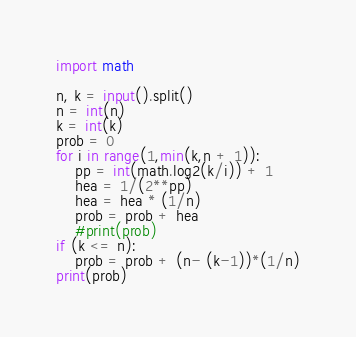<code> <loc_0><loc_0><loc_500><loc_500><_Python_>import math

n, k = input().split()
n = int(n)
k = int(k)
prob = 0
for i in range(1,min(k,n + 1)):
    pp = int(math.log2(k/i)) + 1    
    hea = 1/(2**pp)
    hea = hea * (1/n)
    prob = prob + hea
    #print(prob)
if (k <= n):
    prob = prob + (n- (k-1))*(1/n)
print(prob)
</code> 